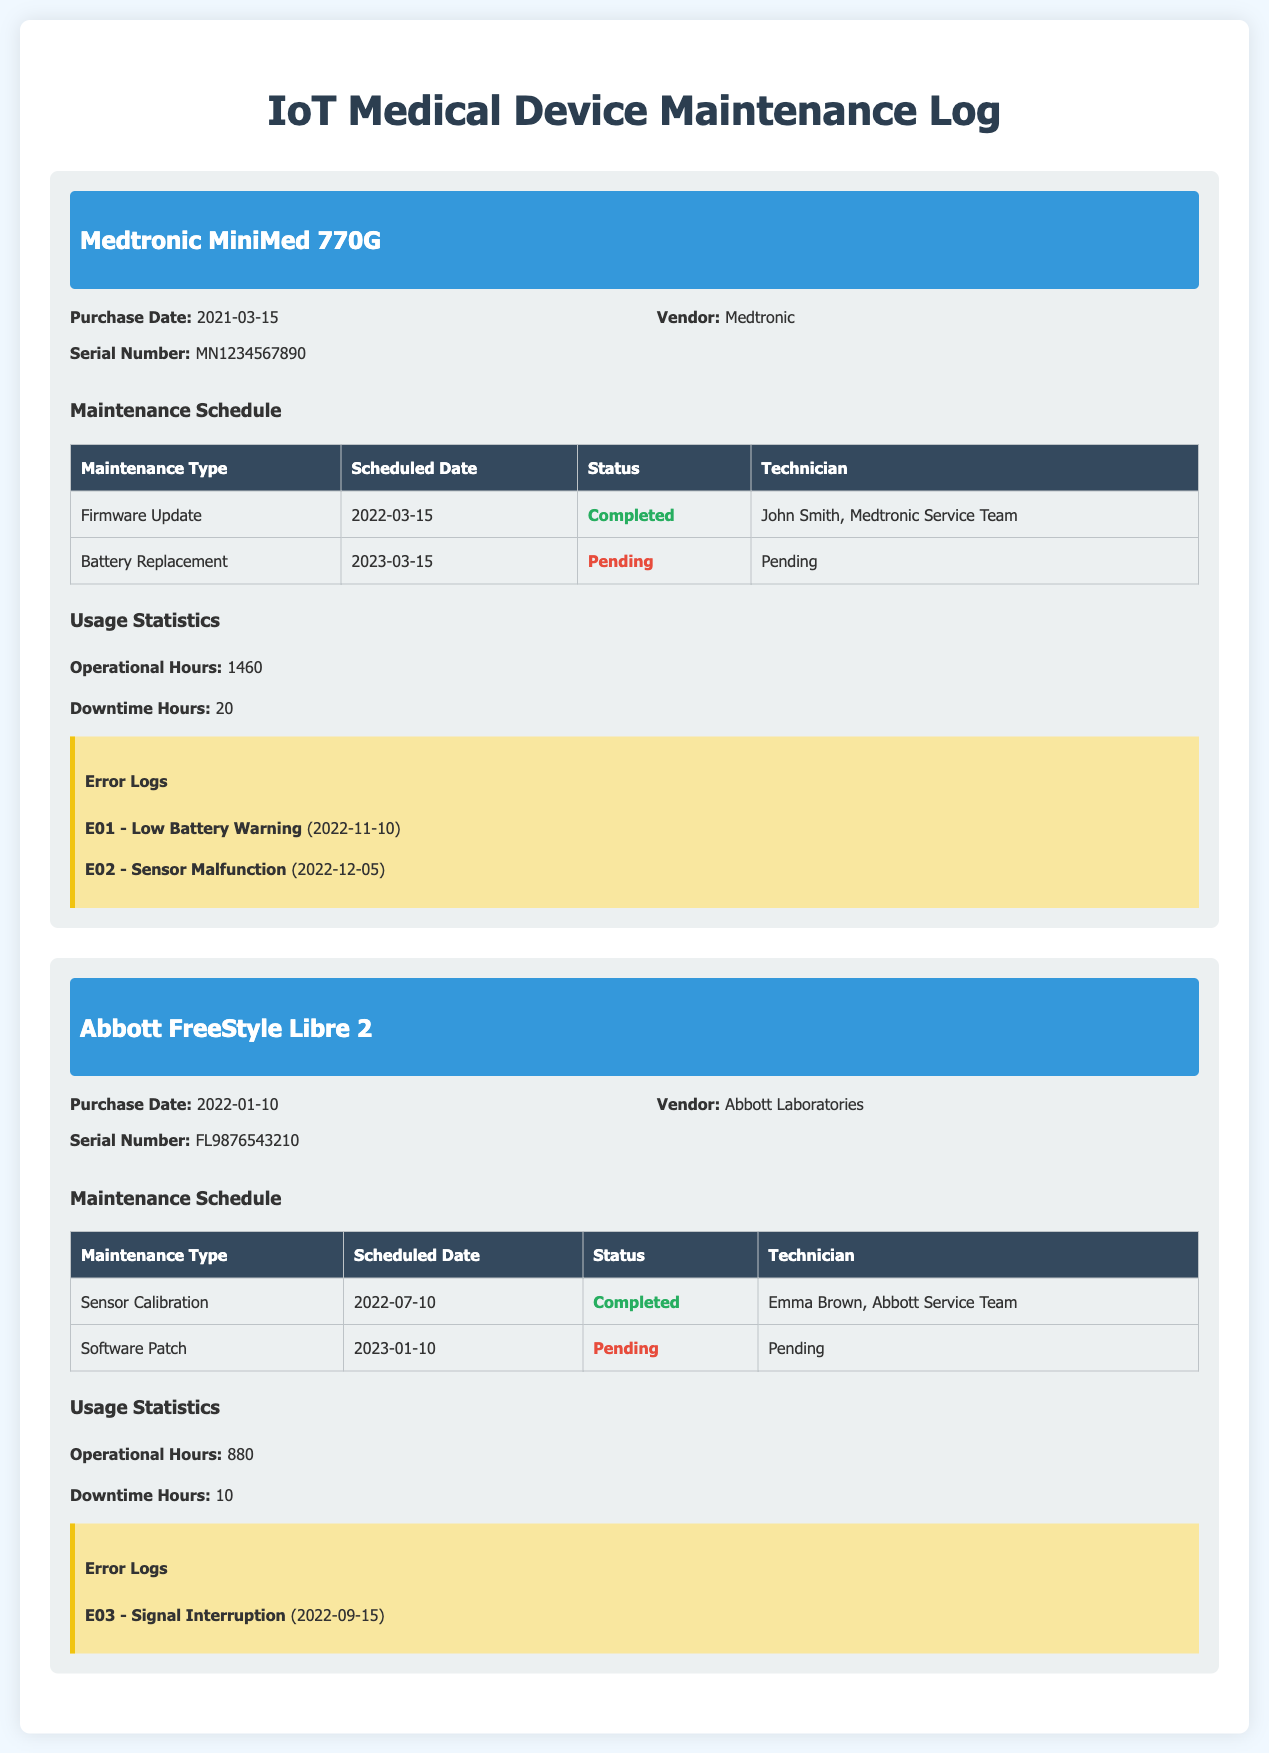What is the purchase date for the Medtronic MiniMed 770G? The purchase date is explicitly stated in the device info section.
Answer: 2021-03-15 Who is the technician for the firmware update maintenance of the Medtronic device? The technician's name is listed in the maintenance schedule table for that specific maintenance type.
Answer: John Smith, Medtronic Service Team How many operational hours are recorded for the Abbott FreeStyle Libre 2? The operational hours are found in the usage statistics section for that device.
Answer: 880 What is the status of the battery replacement for the Medtronic device? The status is provided in the maintenance schedule table, specifically indicating its current state.
Answer: Pending Which error occurred on 2022-11-10 for the Medtronic device? The error log section lists errors along with their occurrence dates.
Answer: E01 - Low Battery Warning What type of maintenance is scheduled for 2023-01-10 for the Abbott device? The maintenance type is specified in the maintenance schedule table with the corresponding date.
Answer: Software Patch How many downtime hours are recorded for the Medtronic MiniMed 770G? The downtime hours are provided in the usage statistics section specific to that device.
Answer: 20 What maintenance type was completed on 2022-07-10 for the Abbott device? The completed maintenance type is listed in the maintenance schedule table along with the date.
Answer: Sensor Calibration 